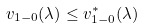<formula> <loc_0><loc_0><loc_500><loc_500>v _ { 1 - 0 } ( \lambda ) \leq v _ { 1 - 0 } ^ { * } ( \lambda )</formula> 